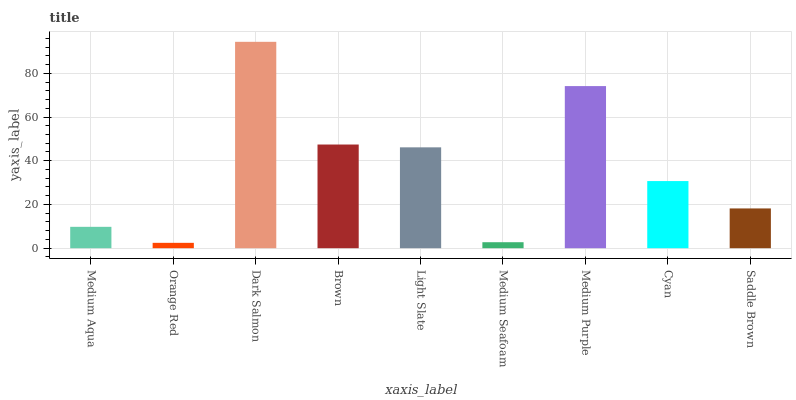Is Orange Red the minimum?
Answer yes or no. Yes. Is Dark Salmon the maximum?
Answer yes or no. Yes. Is Dark Salmon the minimum?
Answer yes or no. No. Is Orange Red the maximum?
Answer yes or no. No. Is Dark Salmon greater than Orange Red?
Answer yes or no. Yes. Is Orange Red less than Dark Salmon?
Answer yes or no. Yes. Is Orange Red greater than Dark Salmon?
Answer yes or no. No. Is Dark Salmon less than Orange Red?
Answer yes or no. No. Is Cyan the high median?
Answer yes or no. Yes. Is Cyan the low median?
Answer yes or no. Yes. Is Dark Salmon the high median?
Answer yes or no. No. Is Orange Red the low median?
Answer yes or no. No. 